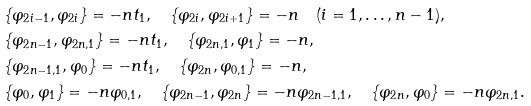Convert formula to latex. <formula><loc_0><loc_0><loc_500><loc_500>& \{ \varphi _ { 2 i - 1 } , \varphi _ { 2 i } \} = - n t _ { 1 } , \quad \{ \varphi _ { 2 i } , \varphi _ { 2 i + 1 } \} = - n \quad ( i = 1 , \dots , n - 1 ) , \\ & \{ \varphi _ { 2 n - 1 } , \varphi _ { 2 n , 1 } \} = - n t _ { 1 } , \quad \{ \varphi _ { 2 n , 1 } , \varphi _ { 1 } \} = - n , \\ & \{ \varphi _ { 2 n - 1 , 1 } , \varphi _ { 0 } \} = - n t _ { 1 } , \quad \{ \varphi _ { 2 n } , \varphi _ { 0 , 1 } \} = - n , \\ & \{ \varphi _ { 0 } , \varphi _ { 1 } \} = - n \varphi _ { 0 , 1 } , \quad \{ \varphi _ { 2 n - 1 } , \varphi _ { 2 n } \} = - n \varphi _ { 2 n - 1 , 1 } , \quad \{ \varphi _ { 2 n } , \varphi _ { 0 } \} = - n \varphi _ { 2 n , 1 } .</formula> 